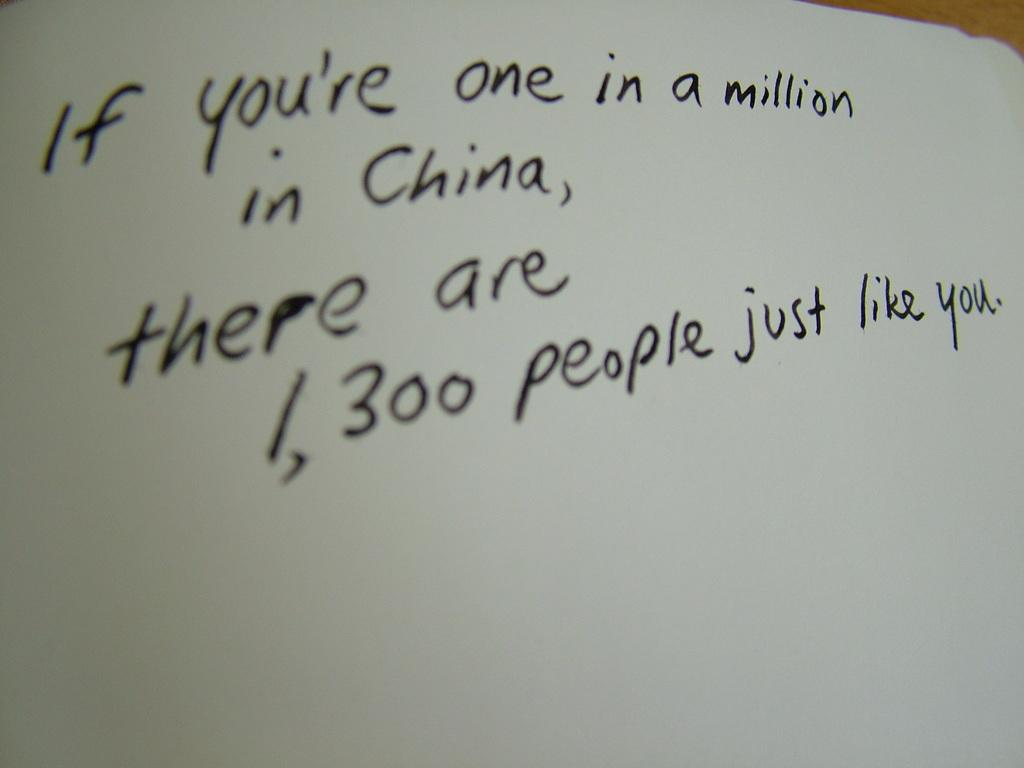What is the primary object in the image? There is text written on a paper in the image. Can you describe the text in the image? Unfortunately, the specific content of the text cannot be determined from the image alone. What might the text be related to? The text could be related to a variety of topics, such as a note, a list, or a message. How many people are smiling in the image? There are no people present in the image, so it is not possible to determine how many people might be smiling. 